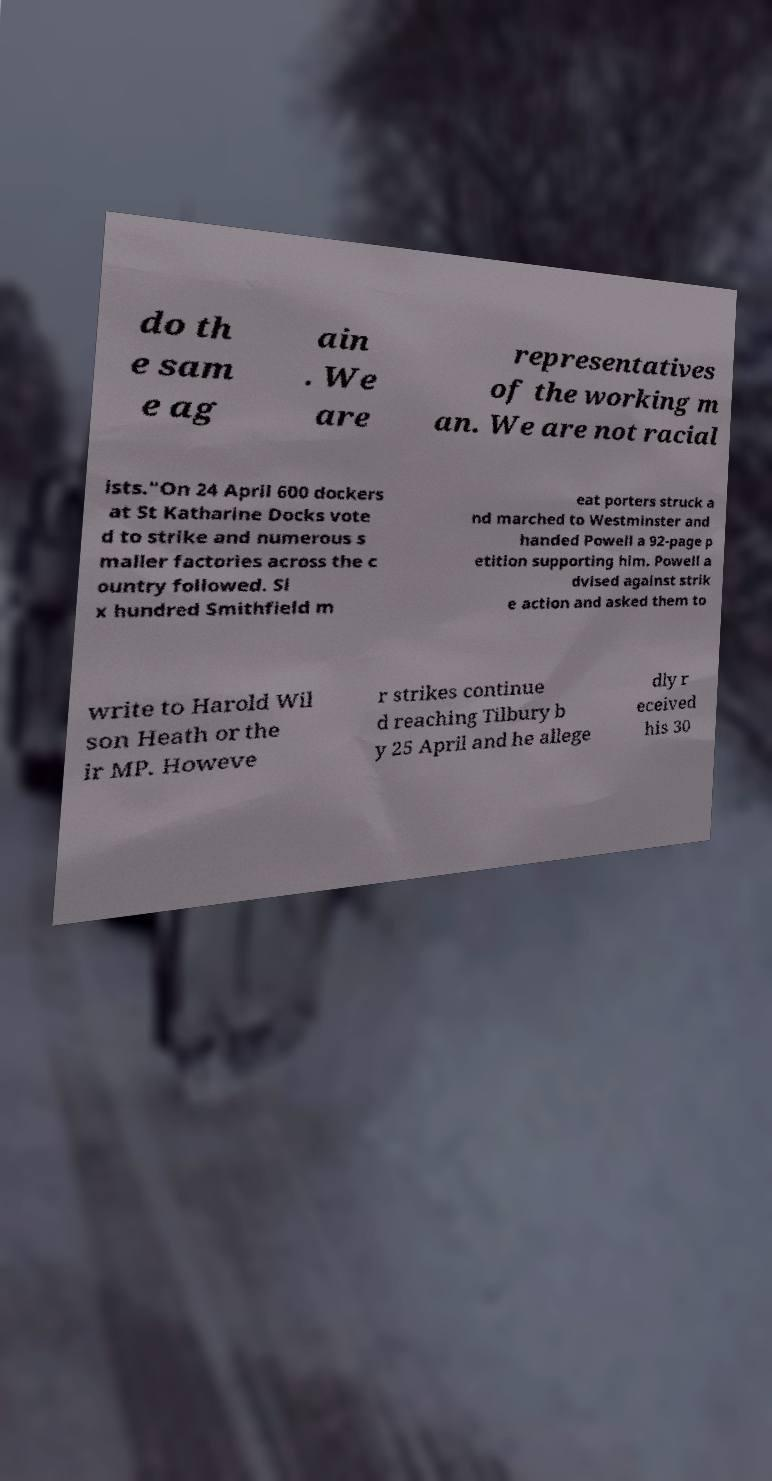What messages or text are displayed in this image? I need them in a readable, typed format. do th e sam e ag ain . We are representatives of the working m an. We are not racial ists."On 24 April 600 dockers at St Katharine Docks vote d to strike and numerous s maller factories across the c ountry followed. Si x hundred Smithfield m eat porters struck a nd marched to Westminster and handed Powell a 92-page p etition supporting him. Powell a dvised against strik e action and asked them to write to Harold Wil son Heath or the ir MP. Howeve r strikes continue d reaching Tilbury b y 25 April and he allege dly r eceived his 30 